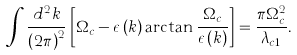Convert formula to latex. <formula><loc_0><loc_0><loc_500><loc_500>\int \frac { d ^ { 2 } k } { \left ( 2 \pi \right ) ^ { 2 } } \left [ \Omega _ { c } - \epsilon \left ( k \right ) \arctan \frac { \Omega _ { c } } { \epsilon \left ( k \right ) } \right ] = \frac { \pi \Omega _ { c } ^ { 2 } } { \lambda _ { c 1 } } .</formula> 